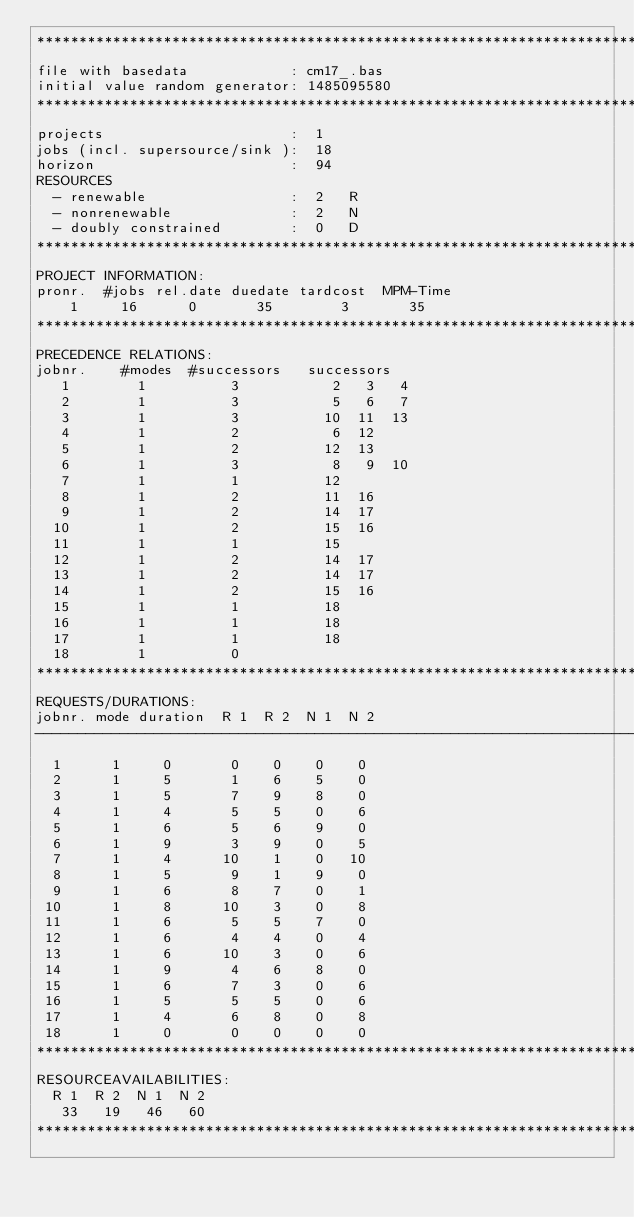<code> <loc_0><loc_0><loc_500><loc_500><_ObjectiveC_>************************************************************************
file with basedata            : cm17_.bas
initial value random generator: 1485095580
************************************************************************
projects                      :  1
jobs (incl. supersource/sink ):  18
horizon                       :  94
RESOURCES
  - renewable                 :  2   R
  - nonrenewable              :  2   N
  - doubly constrained        :  0   D
************************************************************************
PROJECT INFORMATION:
pronr.  #jobs rel.date duedate tardcost  MPM-Time
    1     16      0       35        3       35
************************************************************************
PRECEDENCE RELATIONS:
jobnr.    #modes  #successors   successors
   1        1          3           2   3   4
   2        1          3           5   6   7
   3        1          3          10  11  13
   4        1          2           6  12
   5        1          2          12  13
   6        1          3           8   9  10
   7        1          1          12
   8        1          2          11  16
   9        1          2          14  17
  10        1          2          15  16
  11        1          1          15
  12        1          2          14  17
  13        1          2          14  17
  14        1          2          15  16
  15        1          1          18
  16        1          1          18
  17        1          1          18
  18        1          0        
************************************************************************
REQUESTS/DURATIONS:
jobnr. mode duration  R 1  R 2  N 1  N 2
------------------------------------------------------------------------
  1      1     0       0    0    0    0
  2      1     5       1    6    5    0
  3      1     5       7    9    8    0
  4      1     4       5    5    0    6
  5      1     6       5    6    9    0
  6      1     9       3    9    0    5
  7      1     4      10    1    0   10
  8      1     5       9    1    9    0
  9      1     6       8    7    0    1
 10      1     8      10    3    0    8
 11      1     6       5    5    7    0
 12      1     6       4    4    0    4
 13      1     6      10    3    0    6
 14      1     9       4    6    8    0
 15      1     6       7    3    0    6
 16      1     5       5    5    0    6
 17      1     4       6    8    0    8
 18      1     0       0    0    0    0
************************************************************************
RESOURCEAVAILABILITIES:
  R 1  R 2  N 1  N 2
   33   19   46   60
************************************************************************
</code> 